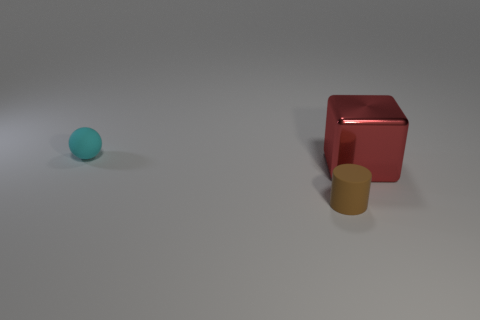What number of tiny cylinders are right of the tiny cylinder?
Make the answer very short. 0. Are the tiny object in front of the cyan sphere and the tiny object that is behind the brown cylinder made of the same material?
Your response must be concise. Yes. The large red metal object to the right of the object that is left of the small thing that is in front of the red thing is what shape?
Offer a very short reply. Cube. What shape is the brown object?
Your answer should be very brief. Cylinder. What is the shape of the matte thing that is the same size as the cylinder?
Your response must be concise. Sphere. What number of other things are there of the same color as the tiny matte sphere?
Offer a terse response. 0. There is a small object behind the large red metallic object; does it have the same shape as the big red thing that is on the right side of the brown object?
Keep it short and to the point. No. How many things are small things that are behind the big red metal block or objects that are behind the big block?
Your answer should be compact. 1. How many other objects are there of the same material as the big red thing?
Ensure brevity in your answer.  0. Does the small thing in front of the large block have the same material as the big block?
Ensure brevity in your answer.  No. 